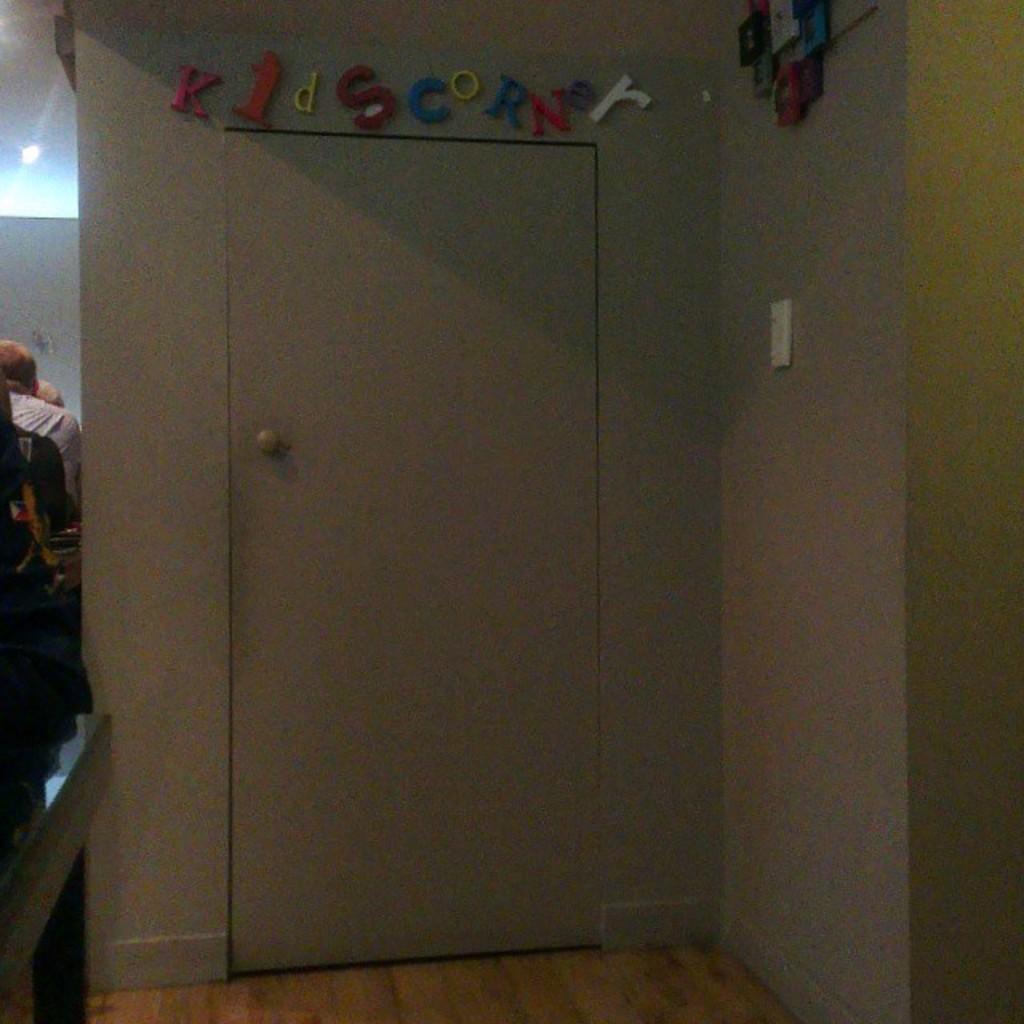Describe this image in one or two sentences. In this picture we can see a door in the front, on the right side there is a wall, on the left side we can see a person is sitting, there is a light at the left top of the picture. 